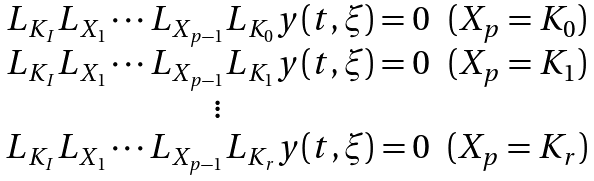Convert formula to latex. <formula><loc_0><loc_0><loc_500><loc_500>\begin{array} { c c } L _ { K _ { I } } L _ { X _ { 1 } } \cdots L _ { X _ { p - 1 } } L _ { K _ { 0 } } y ( t , \xi ) = 0 & ( X _ { p } = K _ { 0 } ) \\ L _ { K _ { I } } L _ { X _ { 1 } } \cdots L _ { X _ { p - 1 } } L _ { K _ { 1 } } y ( t , \xi ) = 0 & ( X _ { p } = K _ { 1 } ) \\ \vdots \\ L _ { K _ { I } } L _ { X _ { 1 } } \cdots L _ { X _ { p - 1 } } L _ { K _ { r } } y ( t , \xi ) = 0 & ( X _ { p } = K _ { r } ) \end{array}</formula> 